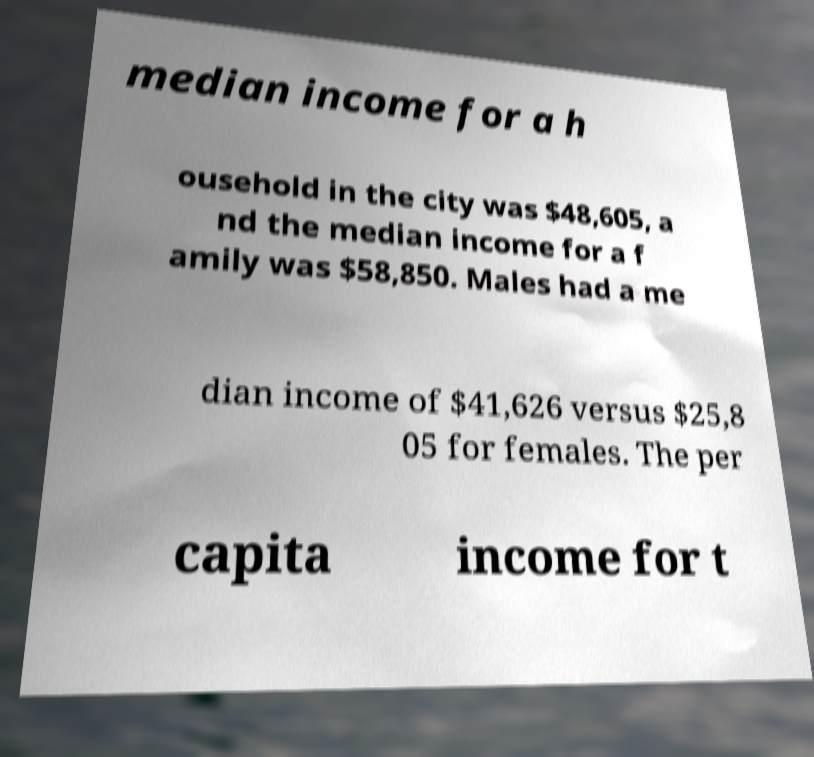Please identify and transcribe the text found in this image. median income for a h ousehold in the city was $48,605, a nd the median income for a f amily was $58,850. Males had a me dian income of $41,626 versus $25,8 05 for females. The per capita income for t 